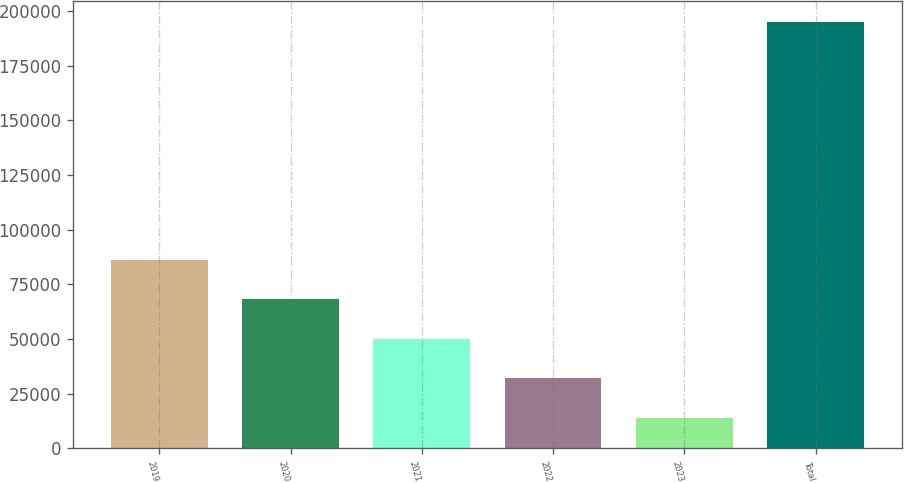<chart> <loc_0><loc_0><loc_500><loc_500><bar_chart><fcel>2019<fcel>2020<fcel>2021<fcel>2022<fcel>2023<fcel>Total<nl><fcel>86345.6<fcel>68257.7<fcel>50169.8<fcel>32081.9<fcel>13994<fcel>194873<nl></chart> 